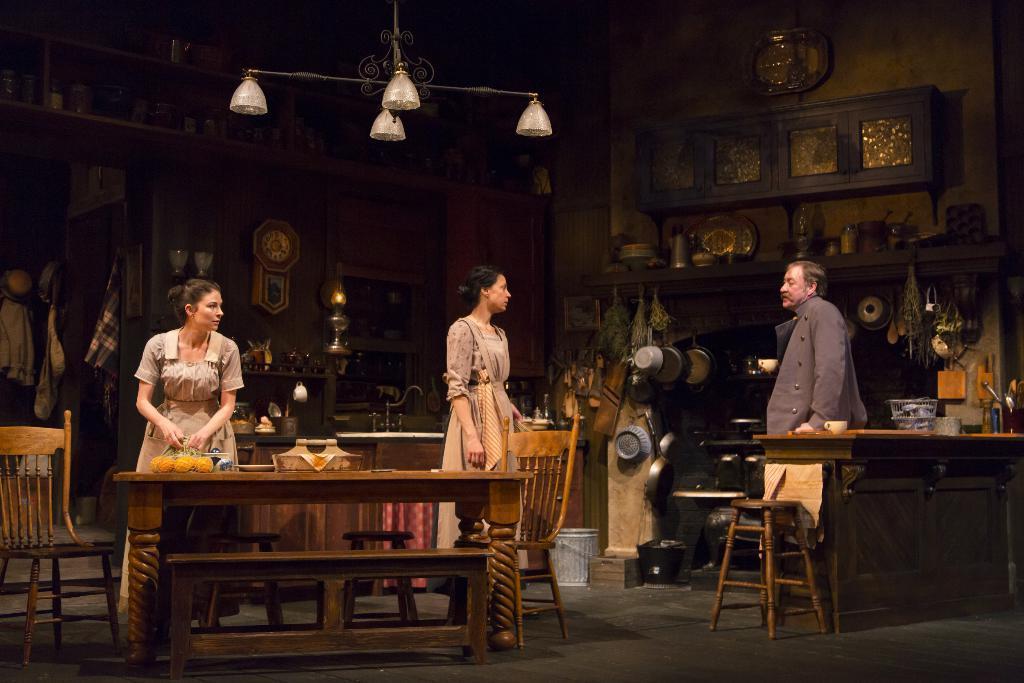In one or two sentences, can you explain what this image depicts? This picture shows three people standing a woman holding a bag in a hand and we see a table and few chairs and some vessels 